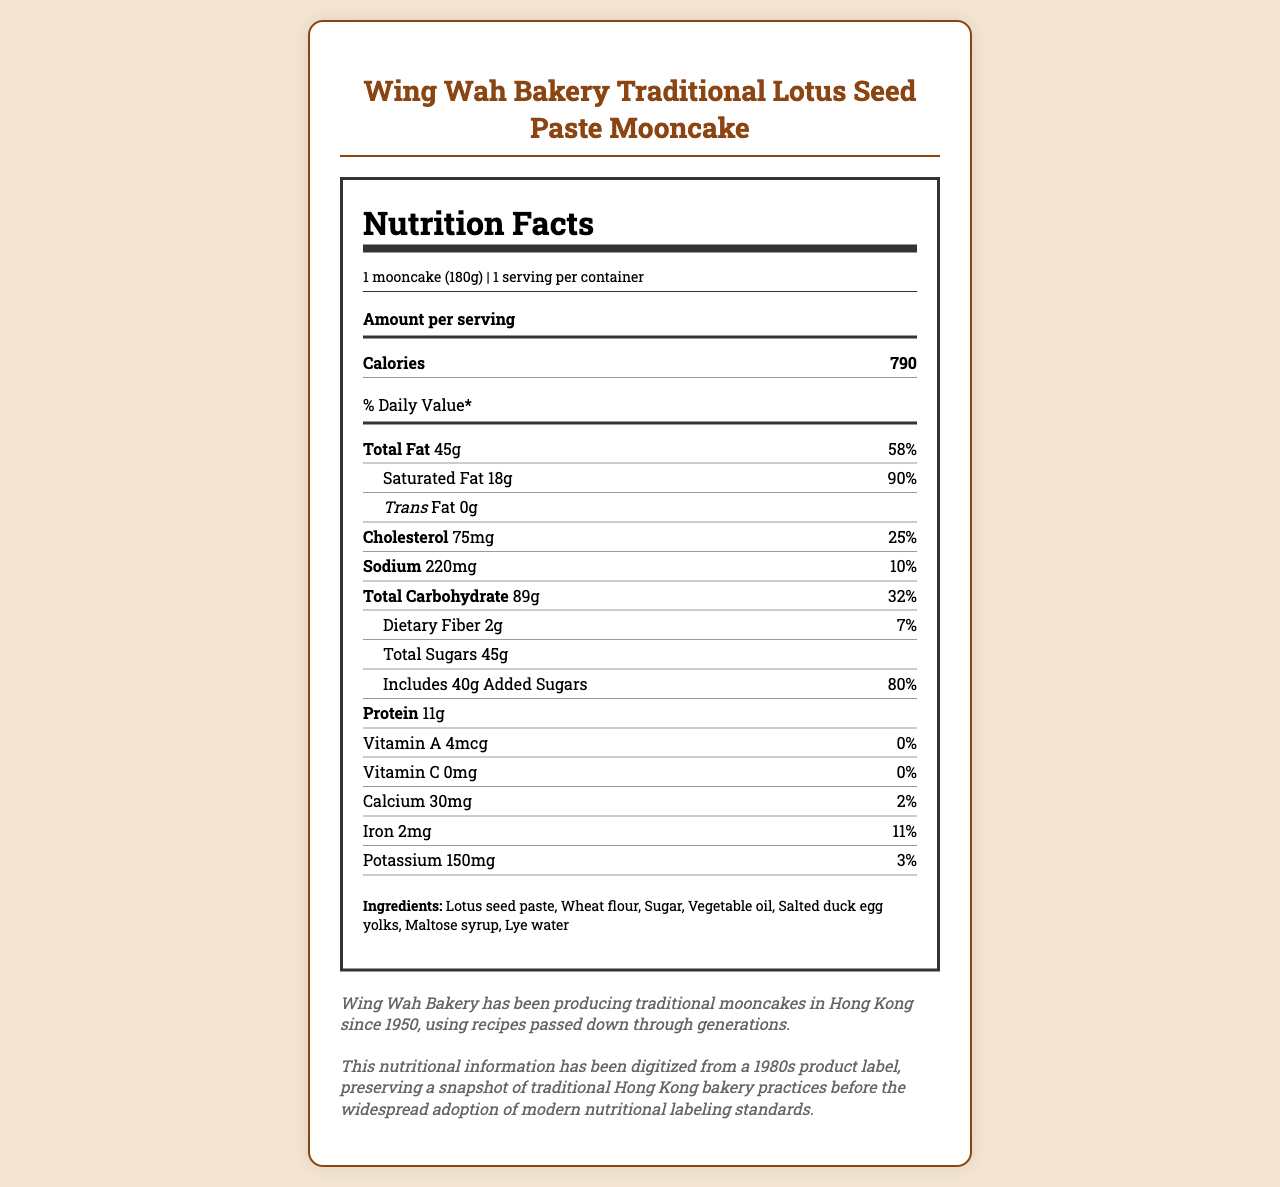what is the serving size? The serving size is clearly listed as "1 mooncake (180g)" in the document.
Answer: 1 mooncake (180g) how many calories are in one serving? The document lists the calorie content as 790 for one serving of the mooncake.
Answer: 790 what is the total fat content per serving? The document states that the total fat content per serving is 45g.
Answer: 45g what is the percentage of daily value for saturated fat? The percentage daily value for saturated fat is 90%, as noted below the saturated fat amount.
Answer: 90% how much protein does the mooncake contain? The mooncake contains 11g of protein per serving, which is indicated in the document.
Answer: 11g how many grams of sugar are in one serving? The document lists the total sugars at 45g.
Answer: 45g how much cholesterol is in one mooncake? The cholesterol content per serving is 75mg as indicated on the label.
Answer: 75mg which ingredient contributes to the mooncake's long shelf life? The document mentions that the high sugar and fat content contribute to the mooncake's long shelf life.
Answer: High sugar and fat content what is the historical significance of Wing Wah Bakery? The historical note clearly states that Wing Wah Bakery has been producing mooncakes since 1950 with traditional recipes handed down through generations.
Answer: Wing Wah Bakery has been producing traditional mooncakes in Hong Kong since 1950, using recipes passed down through generations. what vitamins and minerals are listed, and what are their daily values? A. Vitamin A - 4%, Vitamin C - 0%, Calcium - 2%, Iron - 5%, Potassium - 4% B. Vitamin A - 10%, Vitamin C - 10%, Calcium - 10%, Iron - 10%, Potassium - 10% C. Vitamin A - 20%, Vitamin C - 20%, Calcium - 15%, Iron - 10%, Potassium - 11% Option A matches the values listed in the document: Vitamin A 4%, Vitamin C 0%, Calcium 2%, Iron 5%, and Potassium 4%.
Answer: A how much added sugars does the mooncake contain? A. 20g B. 30g C. 40g The document states that the mooncake includes 40g of added sugars.
Answer: C. 40g can the shelf life of the mooncake be extended without refrigeration? The document explains that the high sugar and fat content allow for a long shelf life without refrigeration, a factor in its historical popularity.
Answer: Yes does the document provide information about modern nutritional labeling standards? The document mentions preserving a snapshot from the 1980s before modern standards, but does not provide detailed information about those standards directly.
Answer: No summarize the main idea of the document. The document offers a comprehensive view of the mooncake's nutritional profile, its traditional significance, preservation methods, and changes in packaging over time.
Answer: The document provides the nutritional facts for Wing Wah Bakery's Traditional Lotus Seed Paste Mooncake, highlighting its caloric and fat content. It also includes historical and cultural notes about the bakery, the significance of mooncakes during the Mid-Autumn Festival, and the evolution of packaging. how many milligrams of potassium are in one serving? The mooncake contains 150mg of potassium per serving, as mentioned in the document.
Answer: 150mg what is the main preservative factor for this mooncake? The document explicitly states that the high sugar and fat content contributes to the mooncake's long shelf life.
Answer: High sugar and fat content does the mooncake contain any trans fat? The document indicates that there is 0g of trans fat in the mooncake.
Answer: No what is the role of mooncakes in the Mid-Autumn Festival? The document describes the cultural significance of mooncakes being an integral part of Mid-Autumn Festival celebrations, symbolizing family reunion and fullness.
Answer: Mooncakes symbolize family reunion and fullness during the Mid-Autumn Festival. when did Wing Wah Bakery start producing traditional mooncakes? The historical note mentions that Wing Wah Bakery has been producing traditional mooncakes since 1950.
Answer: 1950 based on the document, what changes have been made to mooncake packaging? The packaging evolution section explains that early packaging was simple, but now modern packaging has elaborate designs and materials.
Answer: Early packaging used simple paper boxes, while modern versions often feature elaborate designs and materials. does the document list the ingredients of the mooncake? The ingredients are listed in the document as lotus seed paste, wheat flour, sugar, vegetable oil, salted duck egg yolks, maltose syrup, and lye water.
Answer: Yes 